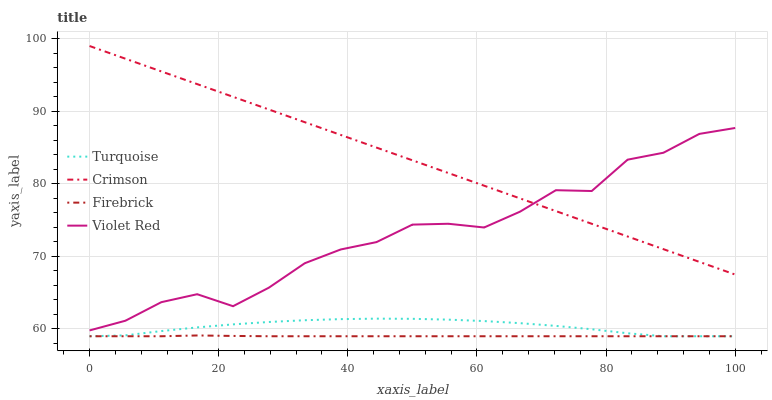Does Firebrick have the minimum area under the curve?
Answer yes or no. Yes. Does Crimson have the maximum area under the curve?
Answer yes or no. Yes. Does Violet Red have the minimum area under the curve?
Answer yes or no. No. Does Violet Red have the maximum area under the curve?
Answer yes or no. No. Is Crimson the smoothest?
Answer yes or no. Yes. Is Violet Red the roughest?
Answer yes or no. Yes. Is Turquoise the smoothest?
Answer yes or no. No. Is Turquoise the roughest?
Answer yes or no. No. Does Turquoise have the lowest value?
Answer yes or no. Yes. Does Violet Red have the lowest value?
Answer yes or no. No. Does Crimson have the highest value?
Answer yes or no. Yes. Does Violet Red have the highest value?
Answer yes or no. No. Is Firebrick less than Crimson?
Answer yes or no. Yes. Is Violet Red greater than Turquoise?
Answer yes or no. Yes. Does Turquoise intersect Firebrick?
Answer yes or no. Yes. Is Turquoise less than Firebrick?
Answer yes or no. No. Is Turquoise greater than Firebrick?
Answer yes or no. No. Does Firebrick intersect Crimson?
Answer yes or no. No. 